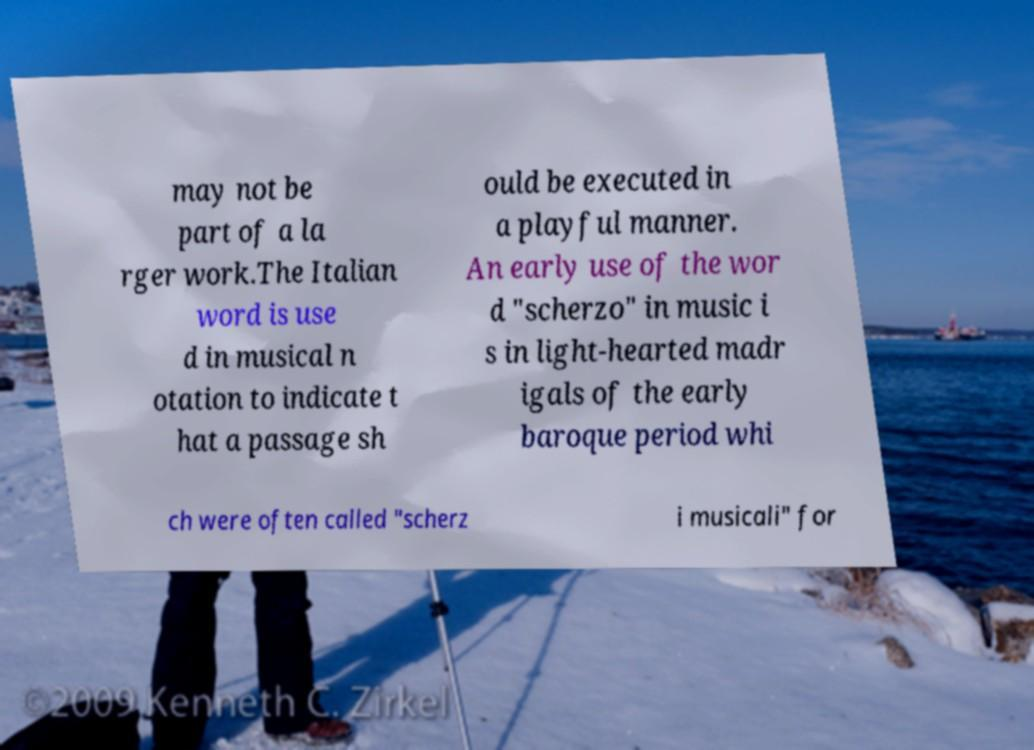I need the written content from this picture converted into text. Can you do that? may not be part of a la rger work.The Italian word is use d in musical n otation to indicate t hat a passage sh ould be executed in a playful manner. An early use of the wor d "scherzo" in music i s in light-hearted madr igals of the early baroque period whi ch were often called "scherz i musicali" for 